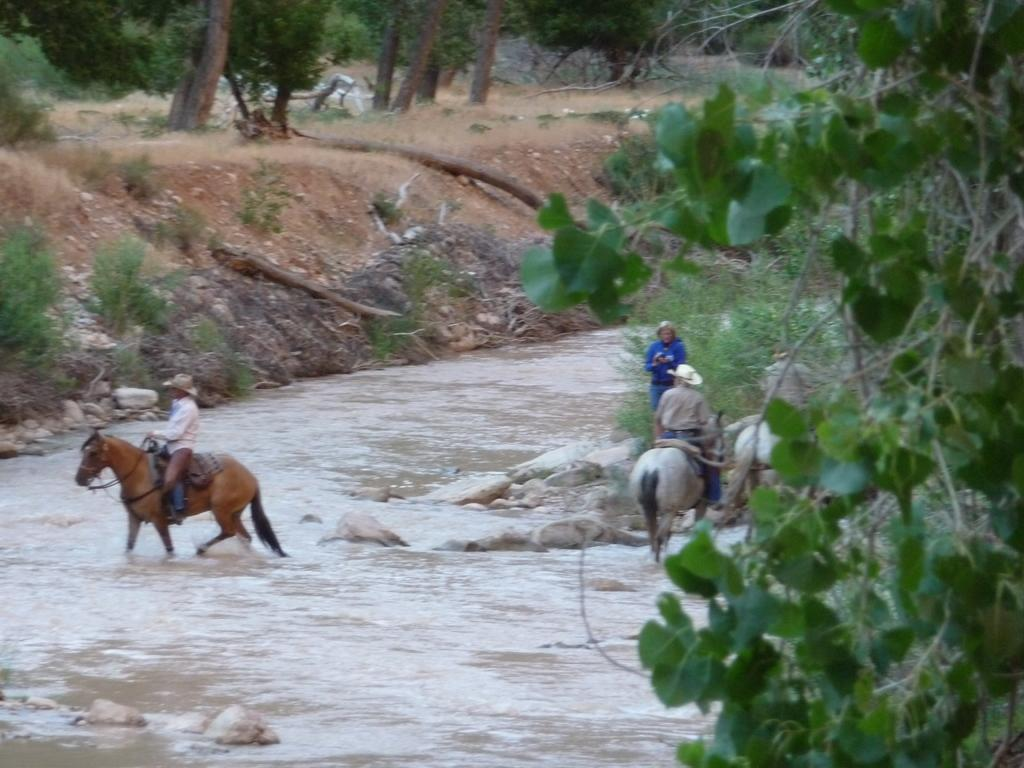What are the two people in the image doing? The two people are riding horses in the image. Where are the horses located? The horses are in the water. What is the person standing on in the image? The person is standing on stones in the image. What type of vegetation can be seen in the image? Plants, grass, and trees are visible in the image. What part of the trees can be seen in the image? The bark of trees is visible in the image. How many trees are grouped together in the image? There is a group of trees in the image. What type of tramp is visible in the image? There is no tramp present in the image. Are the police involved in the scene depicted in the image? There is no indication of police involvement in the image. 